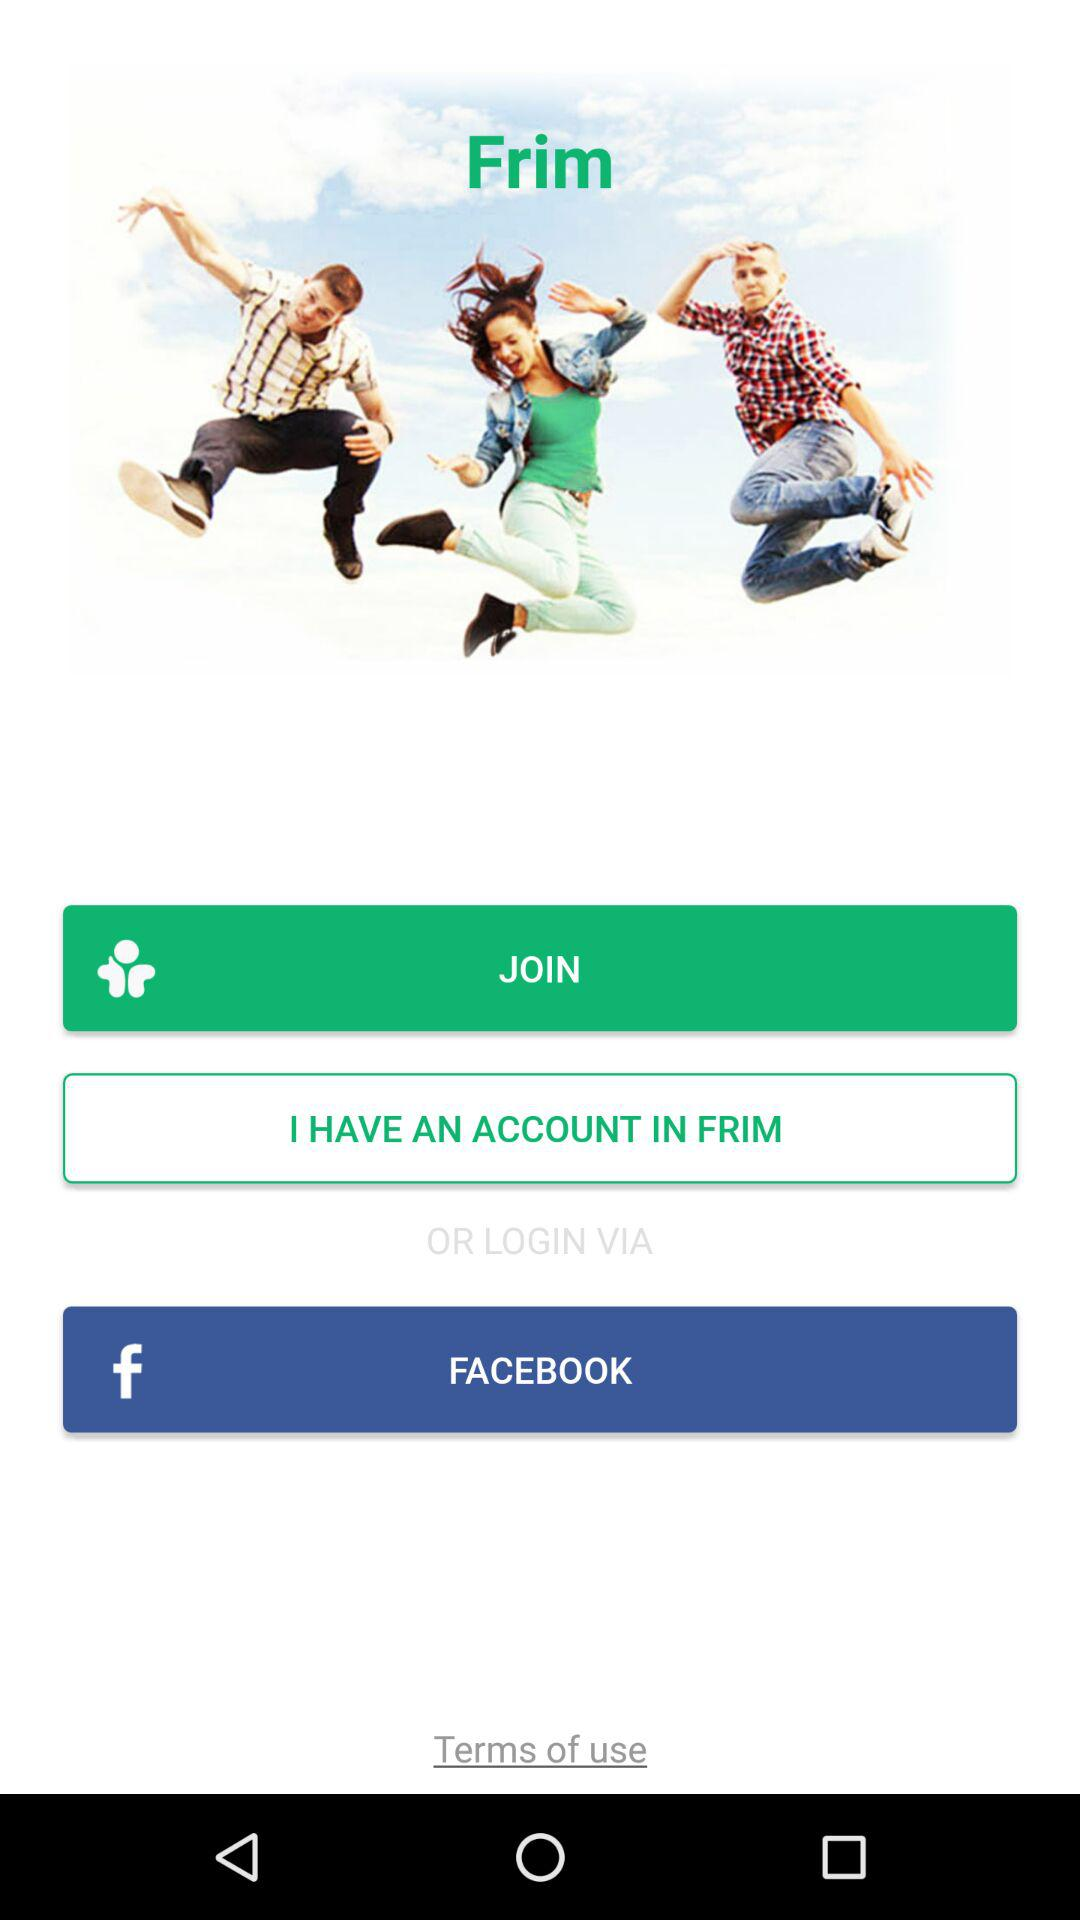What is the application name? The application name is "Frim". 